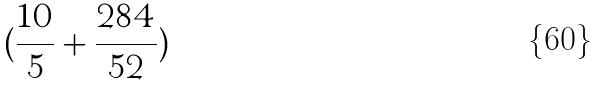<formula> <loc_0><loc_0><loc_500><loc_500>( \frac { 1 0 } { 5 } + \frac { 2 8 4 } { 5 2 } )</formula> 